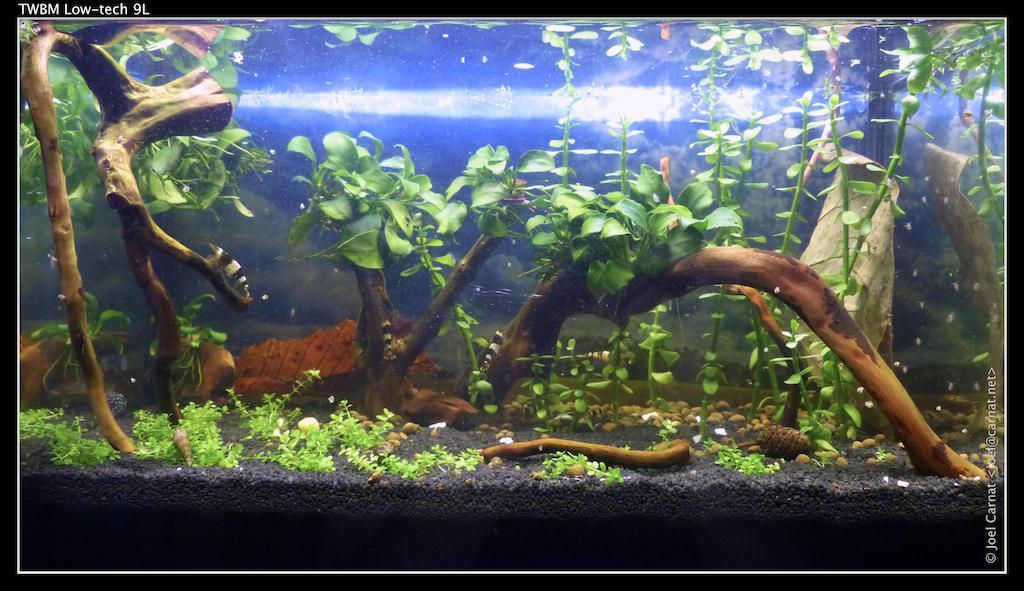What is the main subject of the picture? The main subject of the picture is an aquarium. What types of items can be found inside the aquarium? The aquarium contains plants, stores, water, and fishes. What is the primary liquid in the aquarium? The aquarium contains water. What type of animals can be seen in the aquarium? There are fishes in the aquarium. What type of crime is being committed in the image? There is no crime present in the image; it features an aquarium with plants, stores, water, and fishes. What boundary is visible in the image? There is no boundary visible in the image; it is a picture of an aquarium. 